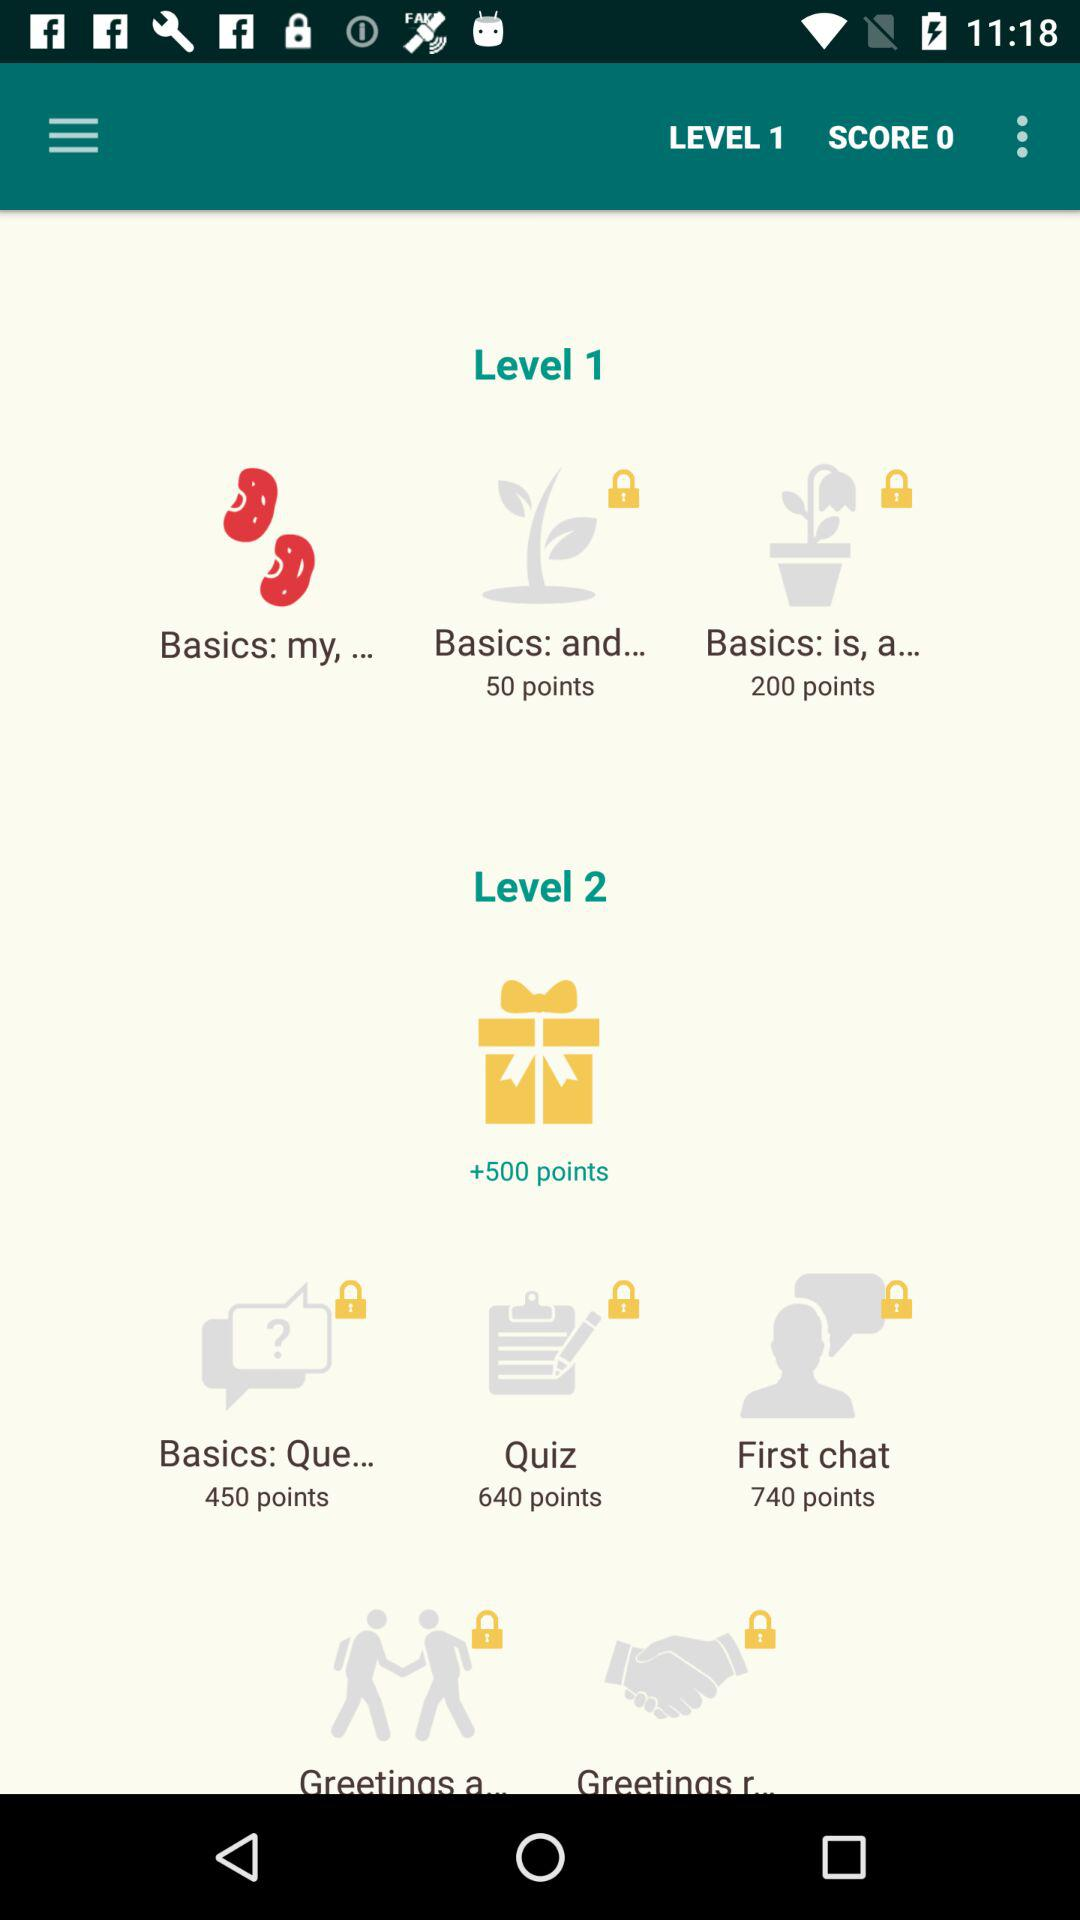How many first chat points in level 2? There are 740 first chat points in level 2. 